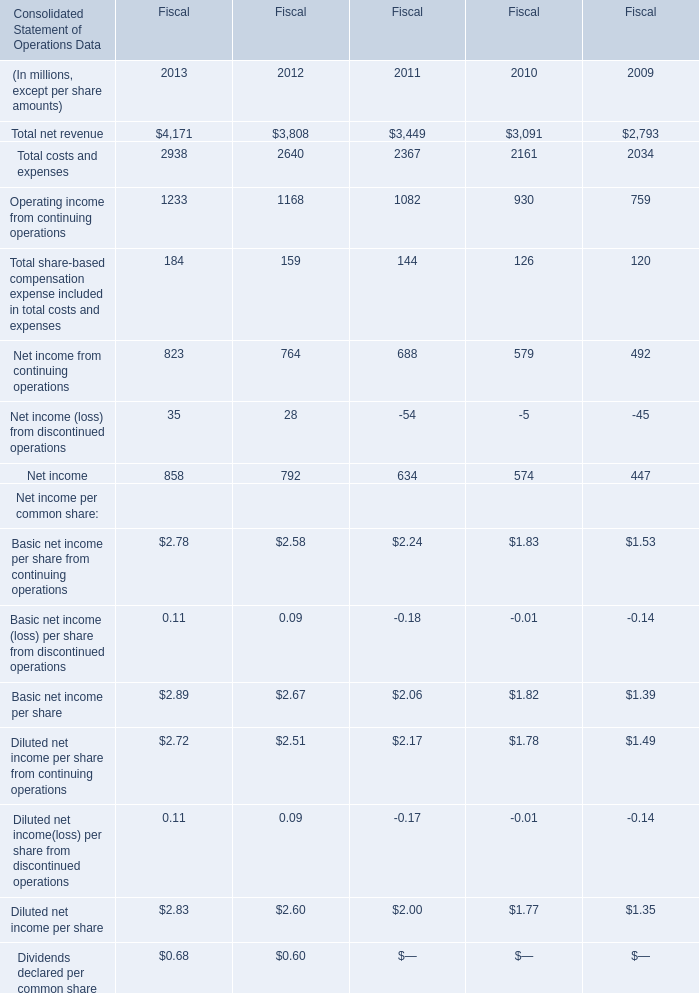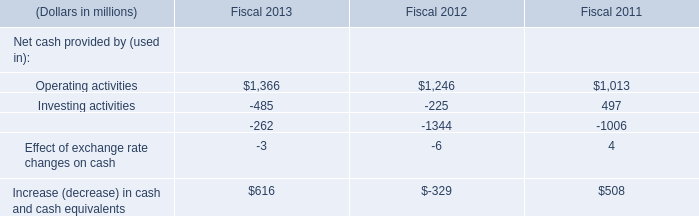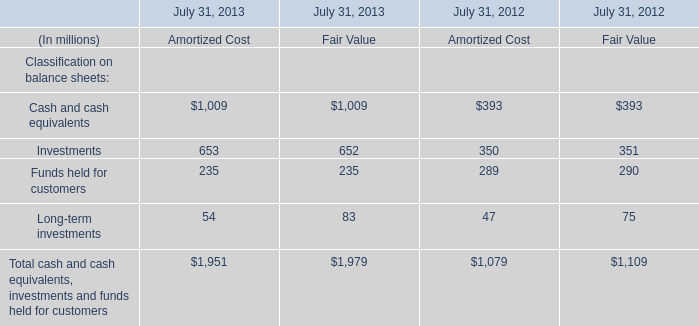What is the average value of Total costs and expenses in Table 0 and Investing activities in Table 1 in 2011? (in million) 
Computations: ((2367 + 497) / 2)
Answer: 1432.0. 